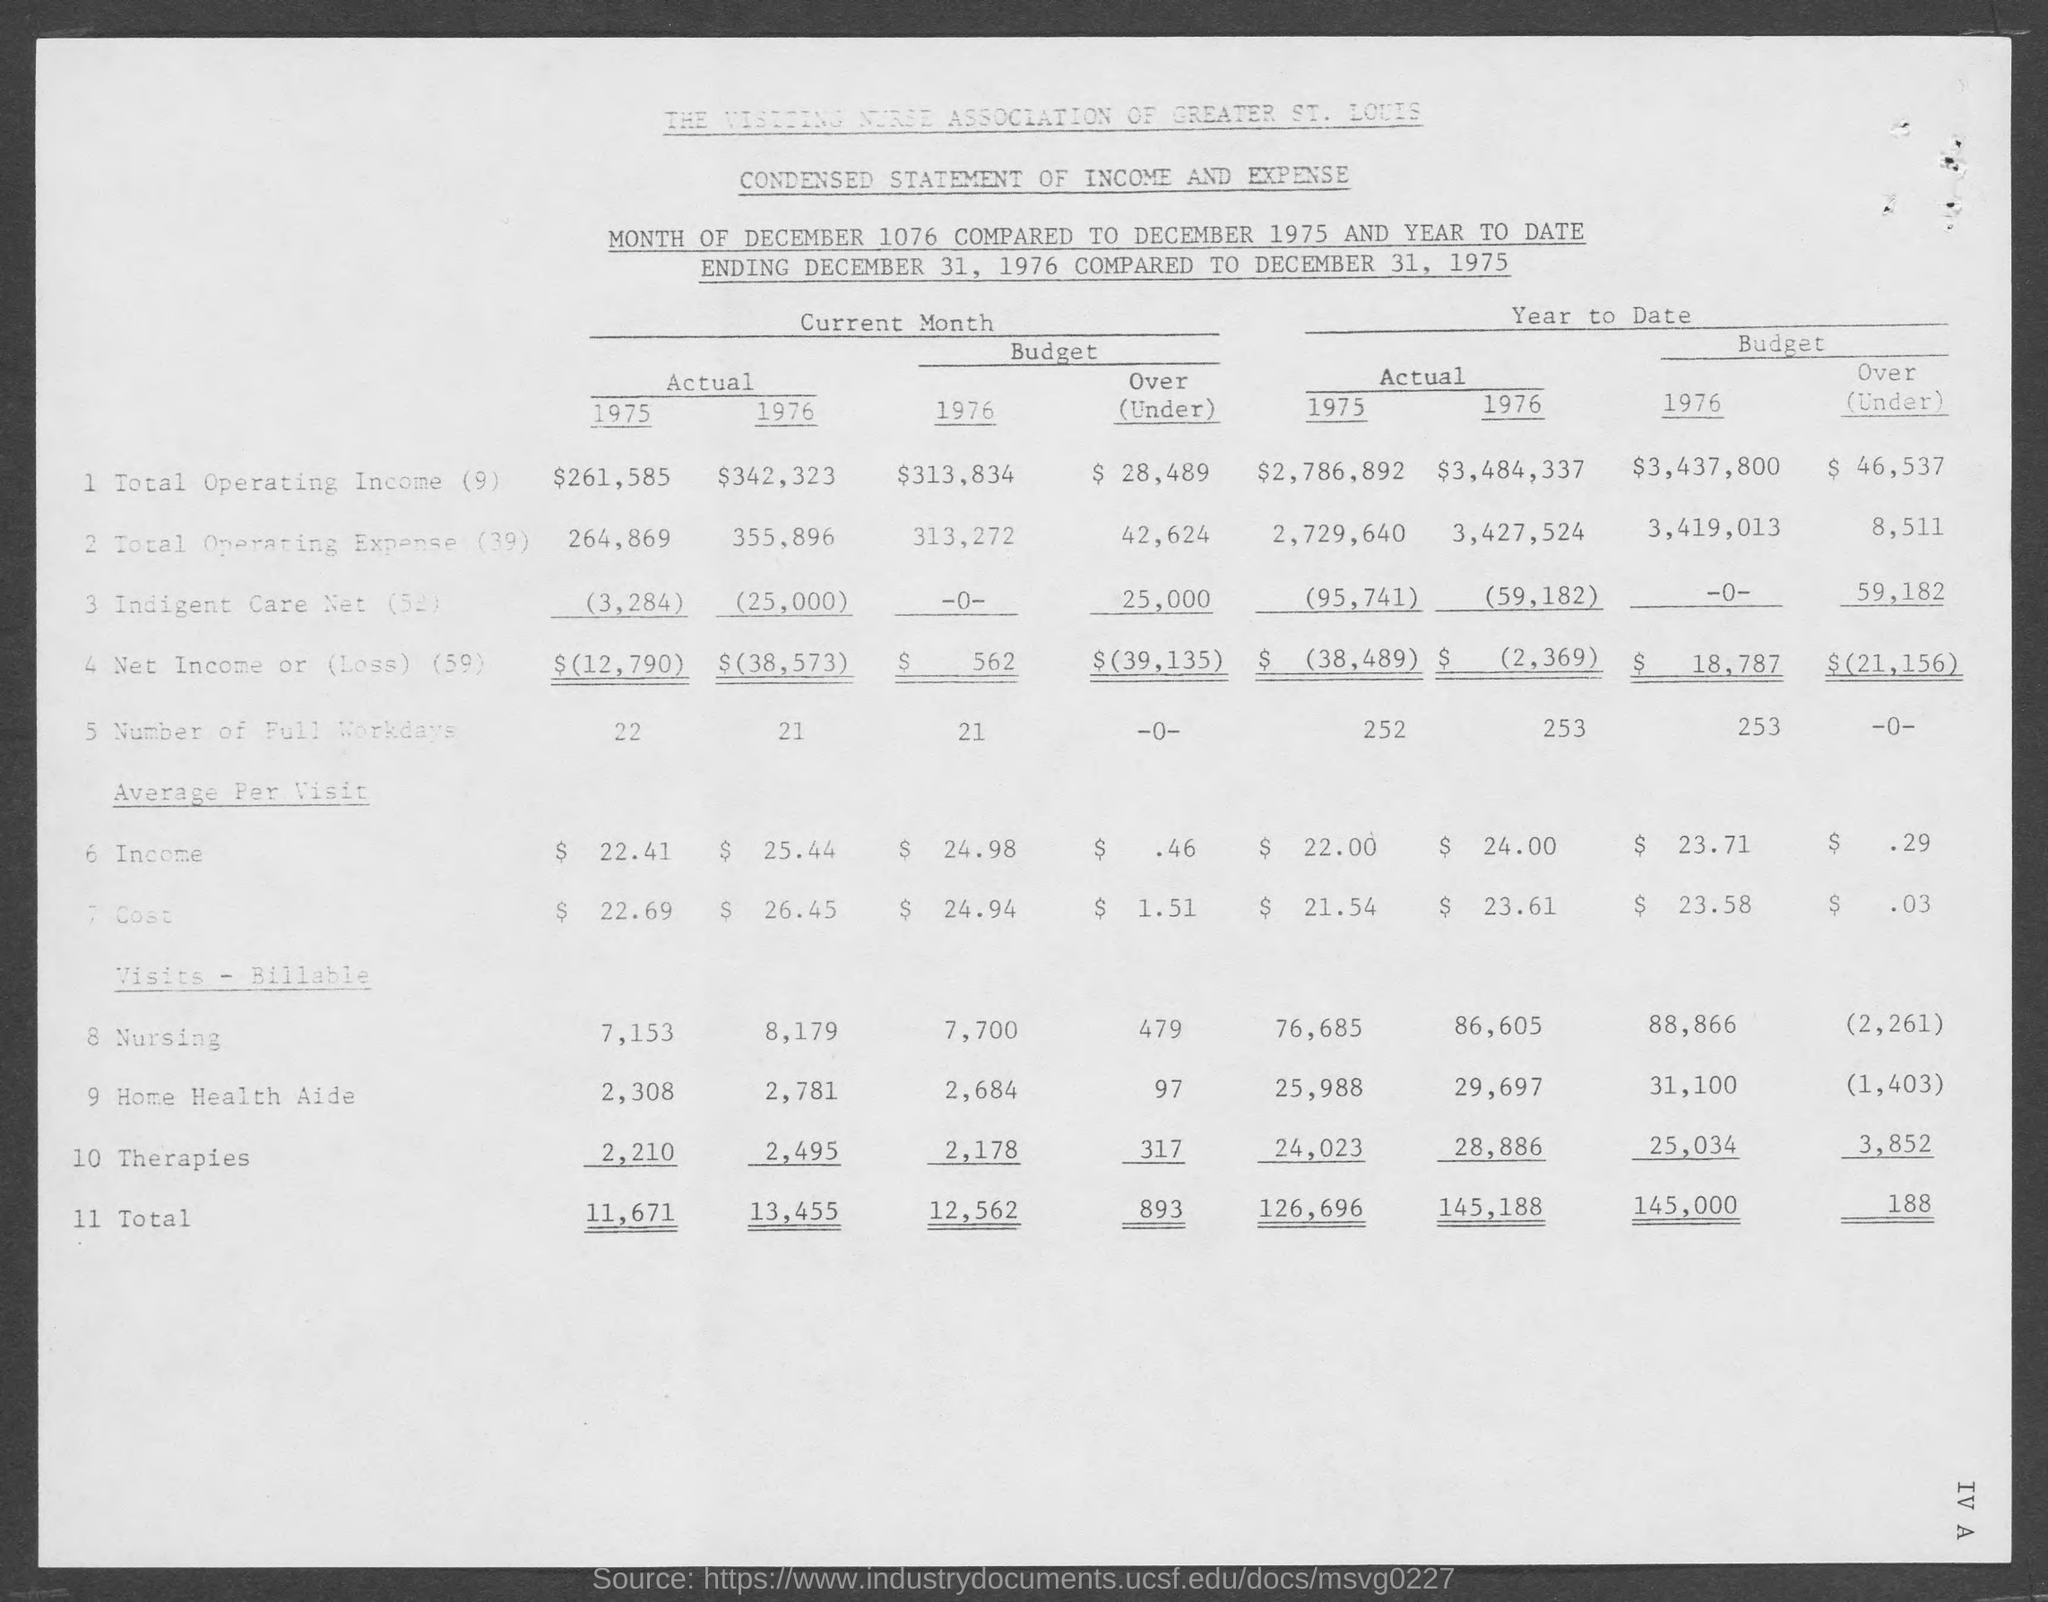What statement is it?
Keep it short and to the point. Condensed statement of income and expense. What is the actual total operating income for 1975?
Your answer should be very brief. $261,585. What is the actual number of full working days in 1975?
Provide a short and direct response. 22. What is the actual average per visit income for 1975?
Offer a very short reply. $22.41. What is the actual total for 1975?
Make the answer very short. 11,671. The actual total operating income is more for which year?
Your response must be concise. 1976. 